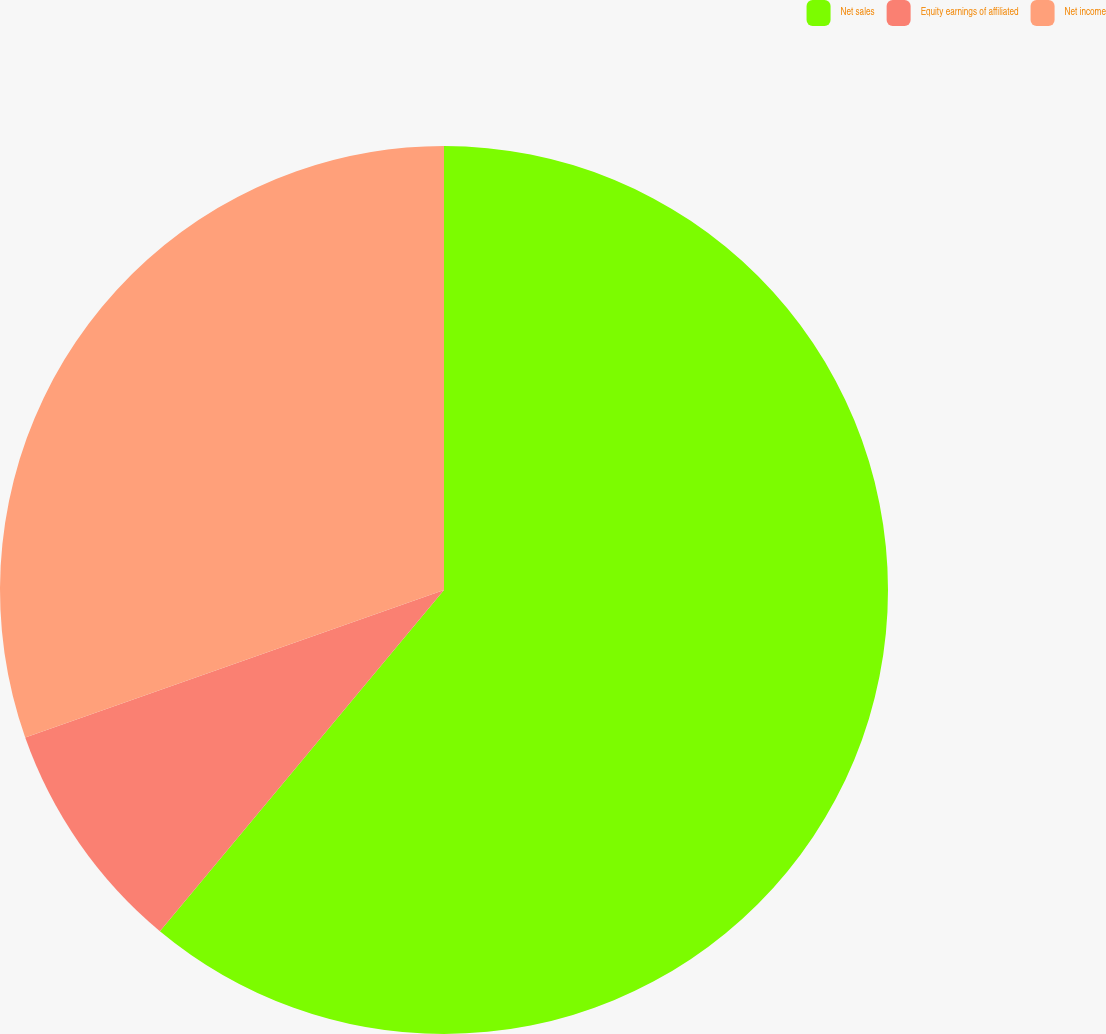<chart> <loc_0><loc_0><loc_500><loc_500><pie_chart><fcel>Net sales<fcel>Equity earnings of affiliated<fcel>Net income<nl><fcel>61.05%<fcel>8.56%<fcel>30.39%<nl></chart> 